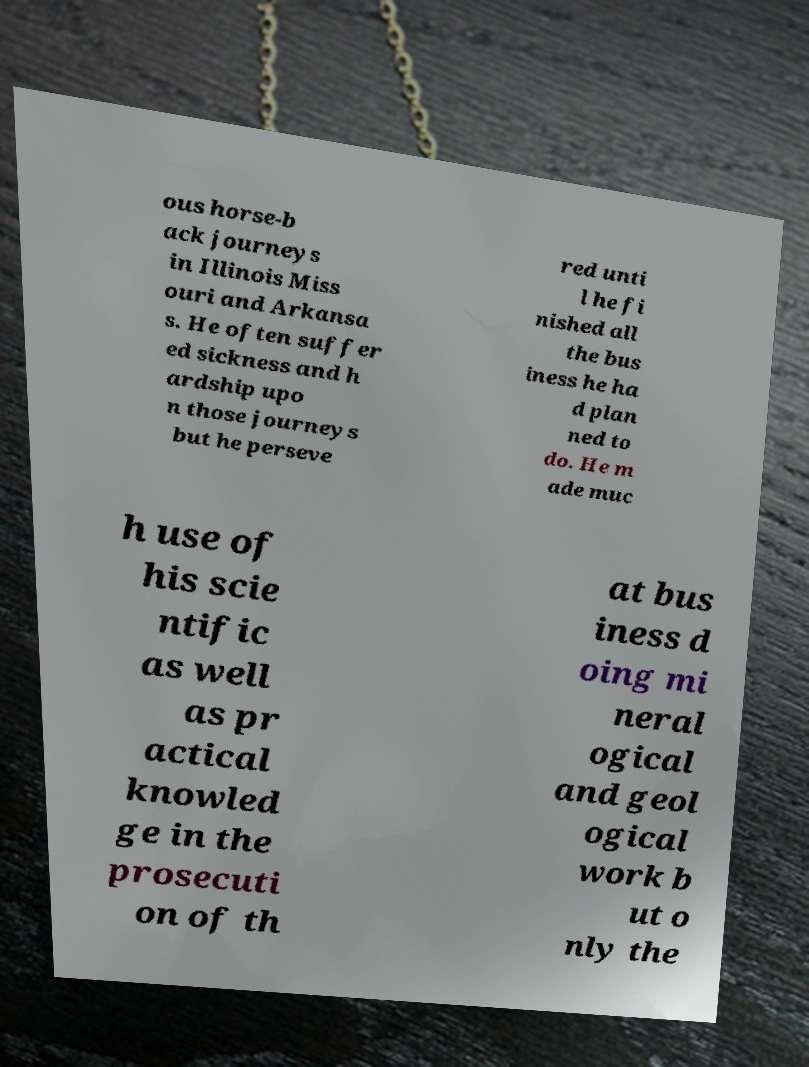Could you assist in decoding the text presented in this image and type it out clearly? ous horse-b ack journeys in Illinois Miss ouri and Arkansa s. He often suffer ed sickness and h ardship upo n those journeys but he perseve red unti l he fi nished all the bus iness he ha d plan ned to do. He m ade muc h use of his scie ntific as well as pr actical knowled ge in the prosecuti on of th at bus iness d oing mi neral ogical and geol ogical work b ut o nly the 